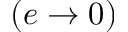<formula> <loc_0><loc_0><loc_500><loc_500>( e \to 0 )</formula> 